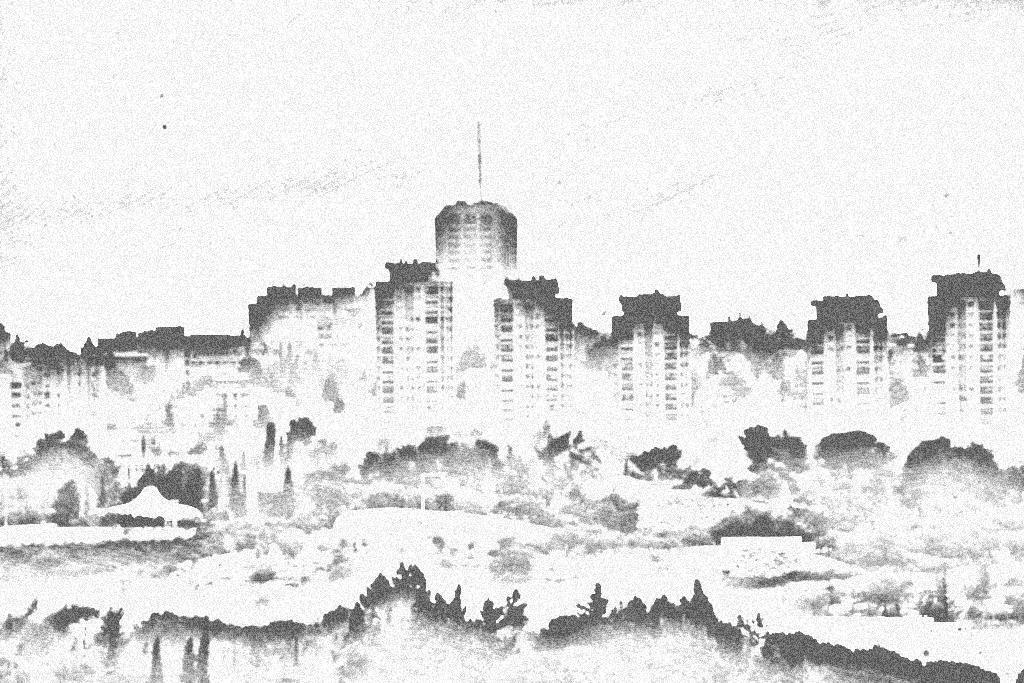How would you summarize this image in a sentence or two? In this black and white image, we can see depiction of buildings. There is a sky at the top of the image. 